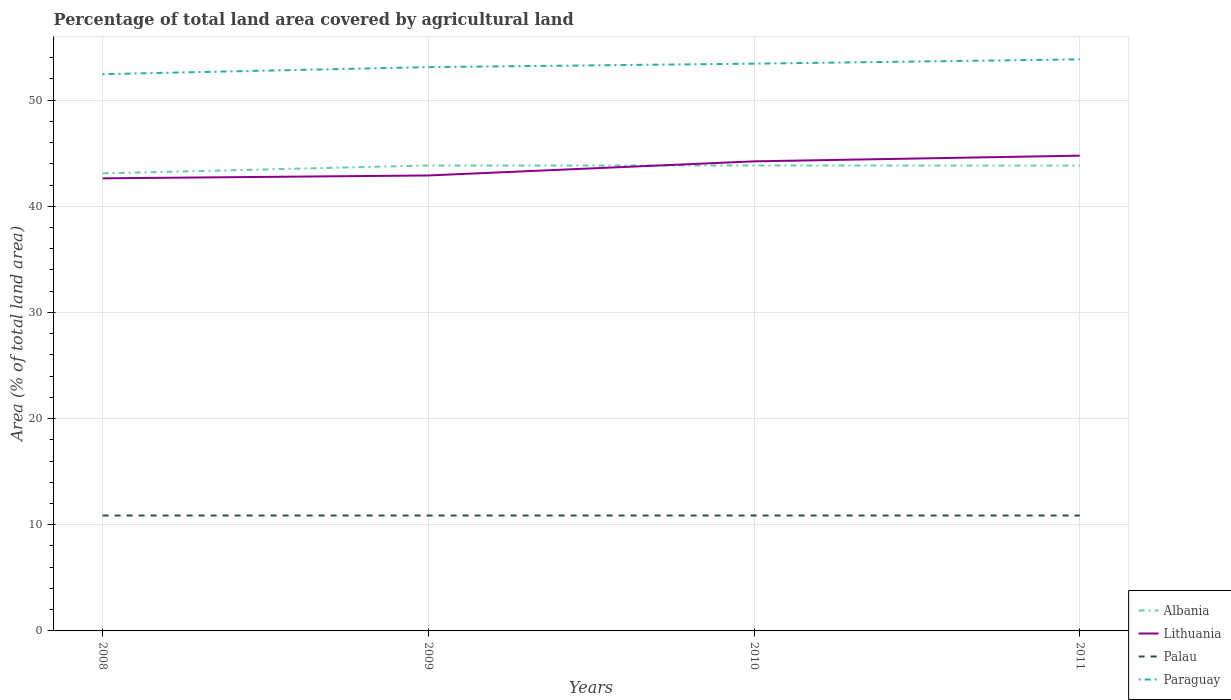How many different coloured lines are there?
Your answer should be very brief. 4. Does the line corresponding to Albania intersect with the line corresponding to Paraguay?
Your answer should be very brief. No. Is the number of lines equal to the number of legend labels?
Give a very brief answer. Yes. Across all years, what is the maximum percentage of agricultural land in Palau?
Provide a short and direct response. 10.87. What is the total percentage of agricultural land in Albania in the graph?
Offer a terse response. 0.01. What is the difference between the highest and the second highest percentage of agricultural land in Palau?
Offer a terse response. 0. How many lines are there?
Provide a succinct answer. 4. How many years are there in the graph?
Provide a short and direct response. 4. What is the difference between two consecutive major ticks on the Y-axis?
Keep it short and to the point. 10. Does the graph contain any zero values?
Offer a very short reply. No. Does the graph contain grids?
Offer a very short reply. Yes. How are the legend labels stacked?
Keep it short and to the point. Vertical. What is the title of the graph?
Offer a terse response. Percentage of total land area covered by agricultural land. Does "East Asia (developing only)" appear as one of the legend labels in the graph?
Provide a short and direct response. No. What is the label or title of the X-axis?
Your answer should be very brief. Years. What is the label or title of the Y-axis?
Ensure brevity in your answer.  Area (% of total land area). What is the Area (% of total land area) in Albania in 2008?
Make the answer very short. 43.1. What is the Area (% of total land area) of Lithuania in 2008?
Make the answer very short. 42.63. What is the Area (% of total land area) of Palau in 2008?
Your answer should be very brief. 10.87. What is the Area (% of total land area) in Paraguay in 2008?
Give a very brief answer. 52.45. What is the Area (% of total land area) of Albania in 2009?
Provide a short and direct response. 43.84. What is the Area (% of total land area) in Lithuania in 2009?
Ensure brevity in your answer.  42.9. What is the Area (% of total land area) in Palau in 2009?
Provide a short and direct response. 10.87. What is the Area (% of total land area) in Paraguay in 2009?
Your answer should be very brief. 53.11. What is the Area (% of total land area) of Albania in 2010?
Your answer should be compact. 43.84. What is the Area (% of total land area) of Lithuania in 2010?
Give a very brief answer. 44.23. What is the Area (% of total land area) of Palau in 2010?
Provide a short and direct response. 10.87. What is the Area (% of total land area) of Paraguay in 2010?
Give a very brief answer. 53.44. What is the Area (% of total land area) in Albania in 2011?
Provide a succinct answer. 43.83. What is the Area (% of total land area) in Lithuania in 2011?
Make the answer very short. 44.77. What is the Area (% of total land area) of Palau in 2011?
Give a very brief answer. 10.87. What is the Area (% of total land area) in Paraguay in 2011?
Provide a short and direct response. 53.84. Across all years, what is the maximum Area (% of total land area) in Albania?
Your answer should be compact. 43.84. Across all years, what is the maximum Area (% of total land area) of Lithuania?
Provide a short and direct response. 44.77. Across all years, what is the maximum Area (% of total land area) of Palau?
Make the answer very short. 10.87. Across all years, what is the maximum Area (% of total land area) in Paraguay?
Your answer should be compact. 53.84. Across all years, what is the minimum Area (% of total land area) of Albania?
Offer a very short reply. 43.1. Across all years, what is the minimum Area (% of total land area) of Lithuania?
Offer a very short reply. 42.63. Across all years, what is the minimum Area (% of total land area) of Palau?
Provide a succinct answer. 10.87. Across all years, what is the minimum Area (% of total land area) of Paraguay?
Provide a short and direct response. 52.45. What is the total Area (% of total land area) in Albania in the graph?
Provide a short and direct response. 174.62. What is the total Area (% of total land area) of Lithuania in the graph?
Make the answer very short. 174.54. What is the total Area (% of total land area) of Palau in the graph?
Your answer should be very brief. 43.48. What is the total Area (% of total land area) of Paraguay in the graph?
Give a very brief answer. 212.83. What is the difference between the Area (% of total land area) of Albania in 2008 and that in 2009?
Offer a very short reply. -0.74. What is the difference between the Area (% of total land area) of Lithuania in 2008 and that in 2009?
Provide a succinct answer. -0.27. What is the difference between the Area (% of total land area) of Palau in 2008 and that in 2009?
Provide a short and direct response. 0. What is the difference between the Area (% of total land area) of Paraguay in 2008 and that in 2009?
Keep it short and to the point. -0.66. What is the difference between the Area (% of total land area) of Albania in 2008 and that in 2010?
Keep it short and to the point. -0.74. What is the difference between the Area (% of total land area) in Lithuania in 2008 and that in 2010?
Your response must be concise. -1.6. What is the difference between the Area (% of total land area) of Paraguay in 2008 and that in 2010?
Offer a very short reply. -0.99. What is the difference between the Area (% of total land area) of Albania in 2008 and that in 2011?
Provide a succinct answer. -0.73. What is the difference between the Area (% of total land area) of Lithuania in 2008 and that in 2011?
Your answer should be very brief. -2.14. What is the difference between the Area (% of total land area) in Palau in 2008 and that in 2011?
Ensure brevity in your answer.  0. What is the difference between the Area (% of total land area) in Paraguay in 2008 and that in 2011?
Provide a short and direct response. -1.39. What is the difference between the Area (% of total land area) of Albania in 2009 and that in 2010?
Ensure brevity in your answer.  0. What is the difference between the Area (% of total land area) of Lithuania in 2009 and that in 2010?
Your answer should be compact. -1.33. What is the difference between the Area (% of total land area) of Paraguay in 2009 and that in 2010?
Your response must be concise. -0.33. What is the difference between the Area (% of total land area) of Albania in 2009 and that in 2011?
Provide a short and direct response. 0.01. What is the difference between the Area (% of total land area) of Lithuania in 2009 and that in 2011?
Give a very brief answer. -1.87. What is the difference between the Area (% of total land area) of Paraguay in 2009 and that in 2011?
Provide a succinct answer. -0.73. What is the difference between the Area (% of total land area) of Albania in 2010 and that in 2011?
Make the answer very short. 0.01. What is the difference between the Area (% of total land area) of Lithuania in 2010 and that in 2011?
Offer a very short reply. -0.54. What is the difference between the Area (% of total land area) of Paraguay in 2010 and that in 2011?
Your answer should be very brief. -0.4. What is the difference between the Area (% of total land area) in Albania in 2008 and the Area (% of total land area) in Lithuania in 2009?
Your answer should be very brief. 0.2. What is the difference between the Area (% of total land area) of Albania in 2008 and the Area (% of total land area) of Palau in 2009?
Keep it short and to the point. 32.23. What is the difference between the Area (% of total land area) in Albania in 2008 and the Area (% of total land area) in Paraguay in 2009?
Make the answer very short. -10.01. What is the difference between the Area (% of total land area) in Lithuania in 2008 and the Area (% of total land area) in Palau in 2009?
Offer a very short reply. 31.76. What is the difference between the Area (% of total land area) of Lithuania in 2008 and the Area (% of total land area) of Paraguay in 2009?
Your response must be concise. -10.47. What is the difference between the Area (% of total land area) of Palau in 2008 and the Area (% of total land area) of Paraguay in 2009?
Offer a very short reply. -42.24. What is the difference between the Area (% of total land area) in Albania in 2008 and the Area (% of total land area) in Lithuania in 2010?
Ensure brevity in your answer.  -1.13. What is the difference between the Area (% of total land area) in Albania in 2008 and the Area (% of total land area) in Palau in 2010?
Your response must be concise. 32.23. What is the difference between the Area (% of total land area) in Albania in 2008 and the Area (% of total land area) in Paraguay in 2010?
Your answer should be very brief. -10.33. What is the difference between the Area (% of total land area) of Lithuania in 2008 and the Area (% of total land area) of Palau in 2010?
Your answer should be compact. 31.76. What is the difference between the Area (% of total land area) of Lithuania in 2008 and the Area (% of total land area) of Paraguay in 2010?
Your answer should be compact. -10.8. What is the difference between the Area (% of total land area) in Palau in 2008 and the Area (% of total land area) in Paraguay in 2010?
Offer a terse response. -42.57. What is the difference between the Area (% of total land area) in Albania in 2008 and the Area (% of total land area) in Lithuania in 2011?
Your answer should be compact. -1.67. What is the difference between the Area (% of total land area) of Albania in 2008 and the Area (% of total land area) of Palau in 2011?
Keep it short and to the point. 32.23. What is the difference between the Area (% of total land area) of Albania in 2008 and the Area (% of total land area) of Paraguay in 2011?
Provide a short and direct response. -10.74. What is the difference between the Area (% of total land area) of Lithuania in 2008 and the Area (% of total land area) of Palau in 2011?
Your answer should be compact. 31.76. What is the difference between the Area (% of total land area) of Lithuania in 2008 and the Area (% of total land area) of Paraguay in 2011?
Offer a very short reply. -11.2. What is the difference between the Area (% of total land area) of Palau in 2008 and the Area (% of total land area) of Paraguay in 2011?
Make the answer very short. -42.97. What is the difference between the Area (% of total land area) of Albania in 2009 and the Area (% of total land area) of Lithuania in 2010?
Offer a terse response. -0.39. What is the difference between the Area (% of total land area) in Albania in 2009 and the Area (% of total land area) in Palau in 2010?
Ensure brevity in your answer.  32.97. What is the difference between the Area (% of total land area) in Albania in 2009 and the Area (% of total land area) in Paraguay in 2010?
Make the answer very short. -9.59. What is the difference between the Area (% of total land area) of Lithuania in 2009 and the Area (% of total land area) of Palau in 2010?
Offer a very short reply. 32.03. What is the difference between the Area (% of total land area) of Lithuania in 2009 and the Area (% of total land area) of Paraguay in 2010?
Provide a short and direct response. -10.53. What is the difference between the Area (% of total land area) in Palau in 2009 and the Area (% of total land area) in Paraguay in 2010?
Your response must be concise. -42.57. What is the difference between the Area (% of total land area) of Albania in 2009 and the Area (% of total land area) of Lithuania in 2011?
Keep it short and to the point. -0.93. What is the difference between the Area (% of total land area) of Albania in 2009 and the Area (% of total land area) of Palau in 2011?
Your answer should be very brief. 32.97. What is the difference between the Area (% of total land area) of Albania in 2009 and the Area (% of total land area) of Paraguay in 2011?
Give a very brief answer. -10. What is the difference between the Area (% of total land area) in Lithuania in 2009 and the Area (% of total land area) in Palau in 2011?
Keep it short and to the point. 32.03. What is the difference between the Area (% of total land area) of Lithuania in 2009 and the Area (% of total land area) of Paraguay in 2011?
Give a very brief answer. -10.93. What is the difference between the Area (% of total land area) of Palau in 2009 and the Area (% of total land area) of Paraguay in 2011?
Give a very brief answer. -42.97. What is the difference between the Area (% of total land area) in Albania in 2010 and the Area (% of total land area) in Lithuania in 2011?
Provide a short and direct response. -0.93. What is the difference between the Area (% of total land area) in Albania in 2010 and the Area (% of total land area) in Palau in 2011?
Keep it short and to the point. 32.97. What is the difference between the Area (% of total land area) in Albania in 2010 and the Area (% of total land area) in Paraguay in 2011?
Your response must be concise. -10. What is the difference between the Area (% of total land area) in Lithuania in 2010 and the Area (% of total land area) in Palau in 2011?
Your response must be concise. 33.36. What is the difference between the Area (% of total land area) of Lithuania in 2010 and the Area (% of total land area) of Paraguay in 2011?
Your response must be concise. -9.61. What is the difference between the Area (% of total land area) of Palau in 2010 and the Area (% of total land area) of Paraguay in 2011?
Offer a terse response. -42.97. What is the average Area (% of total land area) in Albania per year?
Your response must be concise. 43.66. What is the average Area (% of total land area) in Lithuania per year?
Your answer should be very brief. 43.64. What is the average Area (% of total land area) of Palau per year?
Keep it short and to the point. 10.87. What is the average Area (% of total land area) in Paraguay per year?
Keep it short and to the point. 53.21. In the year 2008, what is the difference between the Area (% of total land area) in Albania and Area (% of total land area) in Lithuania?
Provide a succinct answer. 0.47. In the year 2008, what is the difference between the Area (% of total land area) of Albania and Area (% of total land area) of Palau?
Provide a short and direct response. 32.23. In the year 2008, what is the difference between the Area (% of total land area) in Albania and Area (% of total land area) in Paraguay?
Make the answer very short. -9.34. In the year 2008, what is the difference between the Area (% of total land area) in Lithuania and Area (% of total land area) in Palau?
Your response must be concise. 31.76. In the year 2008, what is the difference between the Area (% of total land area) in Lithuania and Area (% of total land area) in Paraguay?
Your response must be concise. -9.81. In the year 2008, what is the difference between the Area (% of total land area) in Palau and Area (% of total land area) in Paraguay?
Provide a short and direct response. -41.58. In the year 2009, what is the difference between the Area (% of total land area) in Albania and Area (% of total land area) in Lithuania?
Provide a short and direct response. 0.94. In the year 2009, what is the difference between the Area (% of total land area) of Albania and Area (% of total land area) of Palau?
Give a very brief answer. 32.97. In the year 2009, what is the difference between the Area (% of total land area) in Albania and Area (% of total land area) in Paraguay?
Provide a succinct answer. -9.27. In the year 2009, what is the difference between the Area (% of total land area) in Lithuania and Area (% of total land area) in Palau?
Your answer should be very brief. 32.03. In the year 2009, what is the difference between the Area (% of total land area) in Lithuania and Area (% of total land area) in Paraguay?
Offer a terse response. -10.2. In the year 2009, what is the difference between the Area (% of total land area) of Palau and Area (% of total land area) of Paraguay?
Provide a succinct answer. -42.24. In the year 2010, what is the difference between the Area (% of total land area) of Albania and Area (% of total land area) of Lithuania?
Ensure brevity in your answer.  -0.39. In the year 2010, what is the difference between the Area (% of total land area) in Albania and Area (% of total land area) in Palau?
Provide a succinct answer. 32.97. In the year 2010, what is the difference between the Area (% of total land area) of Albania and Area (% of total land area) of Paraguay?
Give a very brief answer. -9.59. In the year 2010, what is the difference between the Area (% of total land area) in Lithuania and Area (% of total land area) in Palau?
Ensure brevity in your answer.  33.36. In the year 2010, what is the difference between the Area (% of total land area) of Lithuania and Area (% of total land area) of Paraguay?
Ensure brevity in your answer.  -9.2. In the year 2010, what is the difference between the Area (% of total land area) in Palau and Area (% of total land area) in Paraguay?
Offer a very short reply. -42.57. In the year 2011, what is the difference between the Area (% of total land area) in Albania and Area (% of total land area) in Lithuania?
Offer a very short reply. -0.94. In the year 2011, what is the difference between the Area (% of total land area) of Albania and Area (% of total land area) of Palau?
Your answer should be very brief. 32.96. In the year 2011, what is the difference between the Area (% of total land area) of Albania and Area (% of total land area) of Paraguay?
Offer a very short reply. -10.01. In the year 2011, what is the difference between the Area (% of total land area) of Lithuania and Area (% of total land area) of Palau?
Your answer should be compact. 33.9. In the year 2011, what is the difference between the Area (% of total land area) of Lithuania and Area (% of total land area) of Paraguay?
Offer a very short reply. -9.07. In the year 2011, what is the difference between the Area (% of total land area) of Palau and Area (% of total land area) of Paraguay?
Give a very brief answer. -42.97. What is the ratio of the Area (% of total land area) in Albania in 2008 to that in 2009?
Offer a very short reply. 0.98. What is the ratio of the Area (% of total land area) of Paraguay in 2008 to that in 2009?
Your response must be concise. 0.99. What is the ratio of the Area (% of total land area) in Albania in 2008 to that in 2010?
Your answer should be compact. 0.98. What is the ratio of the Area (% of total land area) of Lithuania in 2008 to that in 2010?
Give a very brief answer. 0.96. What is the ratio of the Area (% of total land area) in Paraguay in 2008 to that in 2010?
Your response must be concise. 0.98. What is the ratio of the Area (% of total land area) in Albania in 2008 to that in 2011?
Give a very brief answer. 0.98. What is the ratio of the Area (% of total land area) in Lithuania in 2008 to that in 2011?
Your answer should be very brief. 0.95. What is the ratio of the Area (% of total land area) of Paraguay in 2008 to that in 2011?
Your answer should be compact. 0.97. What is the ratio of the Area (% of total land area) in Albania in 2009 to that in 2010?
Your response must be concise. 1. What is the ratio of the Area (% of total land area) of Paraguay in 2009 to that in 2010?
Make the answer very short. 0.99. What is the ratio of the Area (% of total land area) of Paraguay in 2009 to that in 2011?
Your answer should be very brief. 0.99. What is the ratio of the Area (% of total land area) in Albania in 2010 to that in 2011?
Keep it short and to the point. 1. What is the ratio of the Area (% of total land area) in Lithuania in 2010 to that in 2011?
Give a very brief answer. 0.99. What is the difference between the highest and the second highest Area (% of total land area) in Albania?
Offer a terse response. 0. What is the difference between the highest and the second highest Area (% of total land area) in Lithuania?
Offer a very short reply. 0.54. What is the difference between the highest and the second highest Area (% of total land area) of Palau?
Your answer should be compact. 0. What is the difference between the highest and the second highest Area (% of total land area) in Paraguay?
Your response must be concise. 0.4. What is the difference between the highest and the lowest Area (% of total land area) in Albania?
Keep it short and to the point. 0.74. What is the difference between the highest and the lowest Area (% of total land area) of Lithuania?
Keep it short and to the point. 2.14. What is the difference between the highest and the lowest Area (% of total land area) in Palau?
Your response must be concise. 0. What is the difference between the highest and the lowest Area (% of total land area) of Paraguay?
Offer a very short reply. 1.39. 